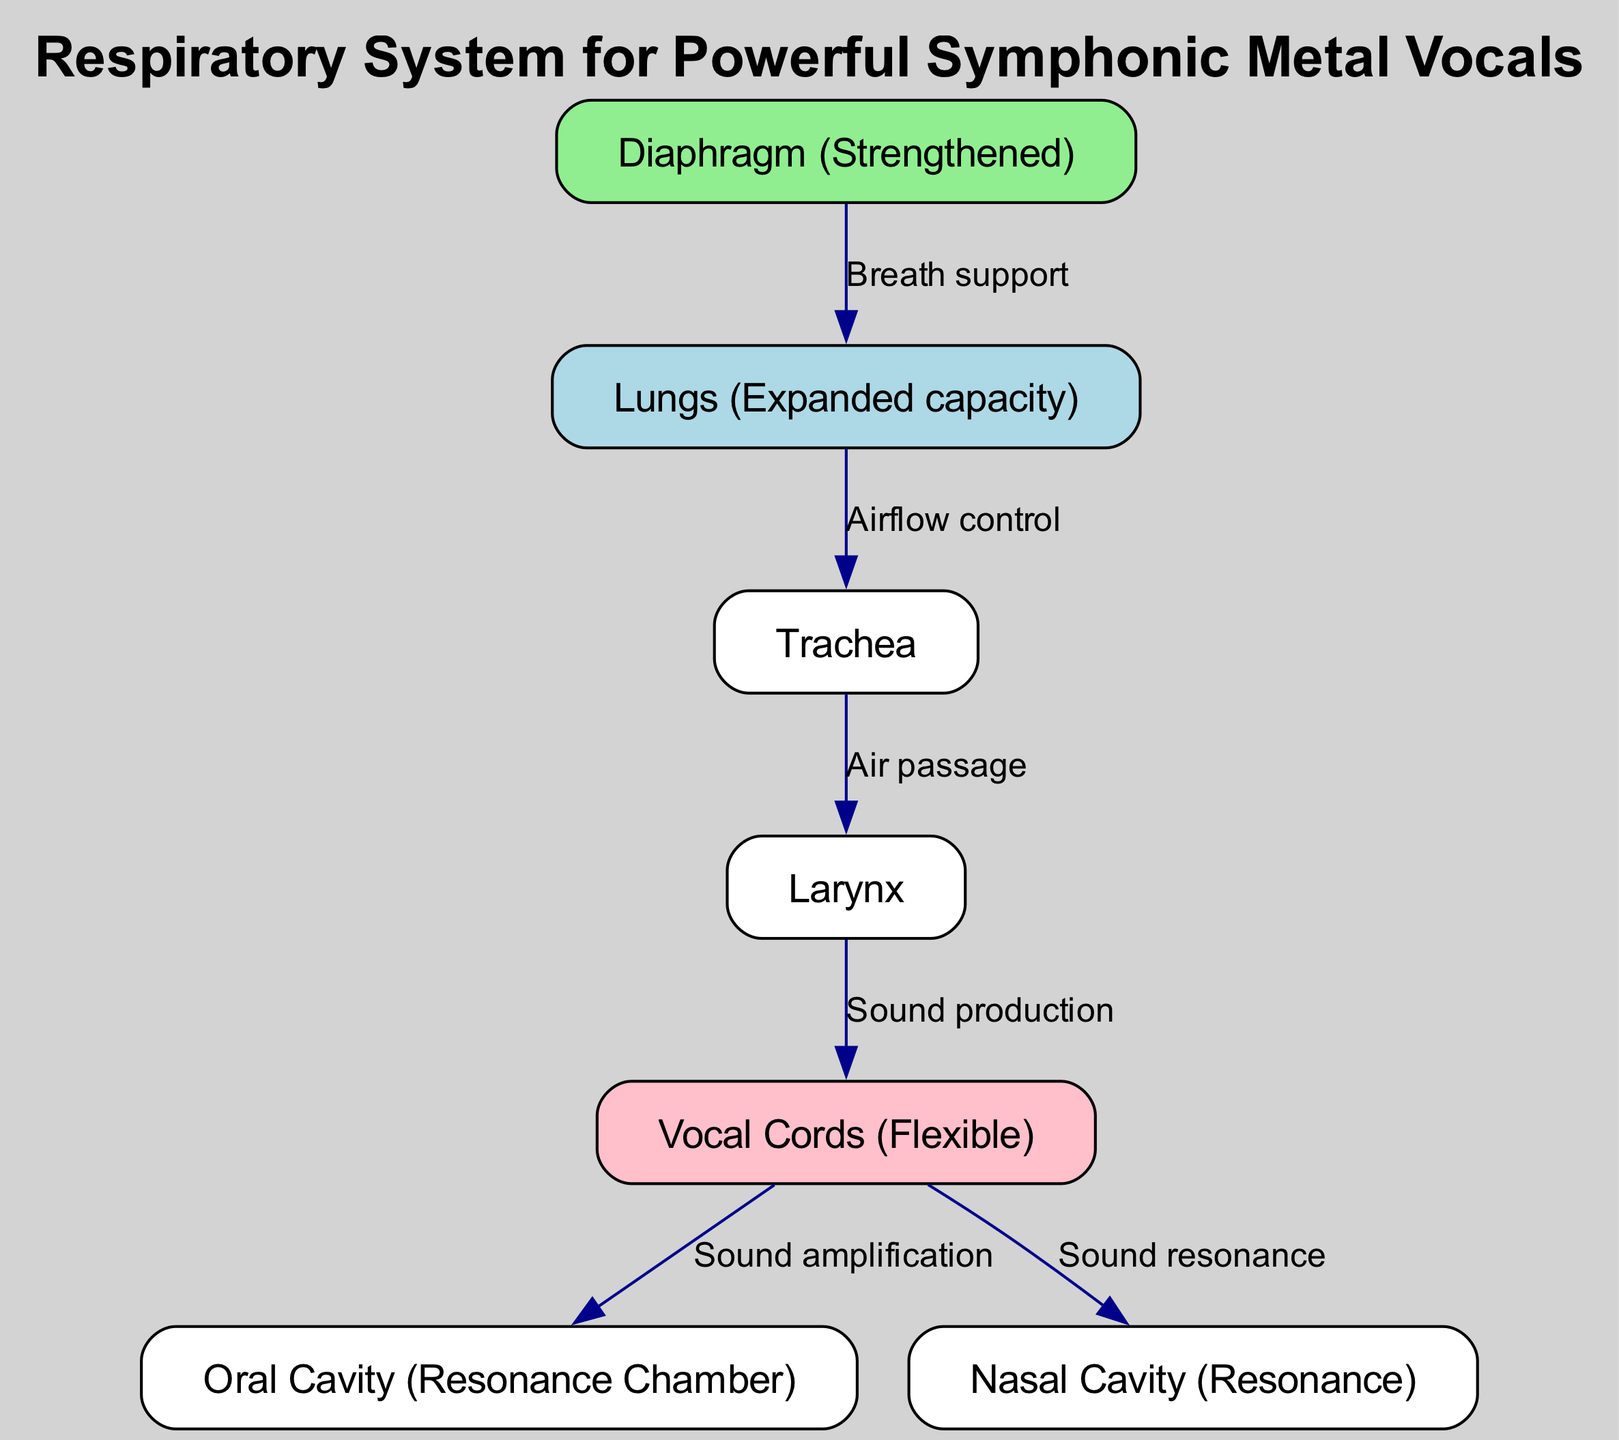What is the main function of the diaphragm? The diaphragm is primarily responsible for breath support, which is indicated by its connection to the lungs in the diagram. This relationship facilitates efficient airflow during vocalizations, crucial for sustaining long notes.
Answer: Breath support How many nodes are present in the diagram? The diagram consists of a total of 7 nodes: lungs, diaphragm, vocal cords, larynx, trachea, oral cavity, and nasal cavity, showcasing various components of the respiratory system.
Answer: 7 Which structure provides sound amplification? The vocal cords are depicted as directly connected to the oral cavity, indicating their role in sound amplification during vocalizations.
Answer: Oral cavity What connects the trachea and larynx? The diagram shows a direct connection labeled as air passage between the trachea and larynx, signifying the pathway for airflow necessary for sound production.
Answer: Air passage How do the vocal cords relate to the nasal cavity? The vocal cords are connected to the nasal cavity through a labeled edge indicating sound resonance. This relationship suggests that the nasal cavity plays a role in enhancing the sound produced by the vocal cords.
Answer: Sound resonance What is the purpose of the lungs in this diagram? The lungs are described as having expanded capacity, which is crucial for providing a sufficient volume of air necessary for powerful vocal performances typical in symphonic metal.
Answer: Expanded capacity Which structure is primarily associated with sound production? The larynx is indicated in the diagram as the structure that directly produces sound, as shown by its connection to the vocal cords.
Answer: Larynx 